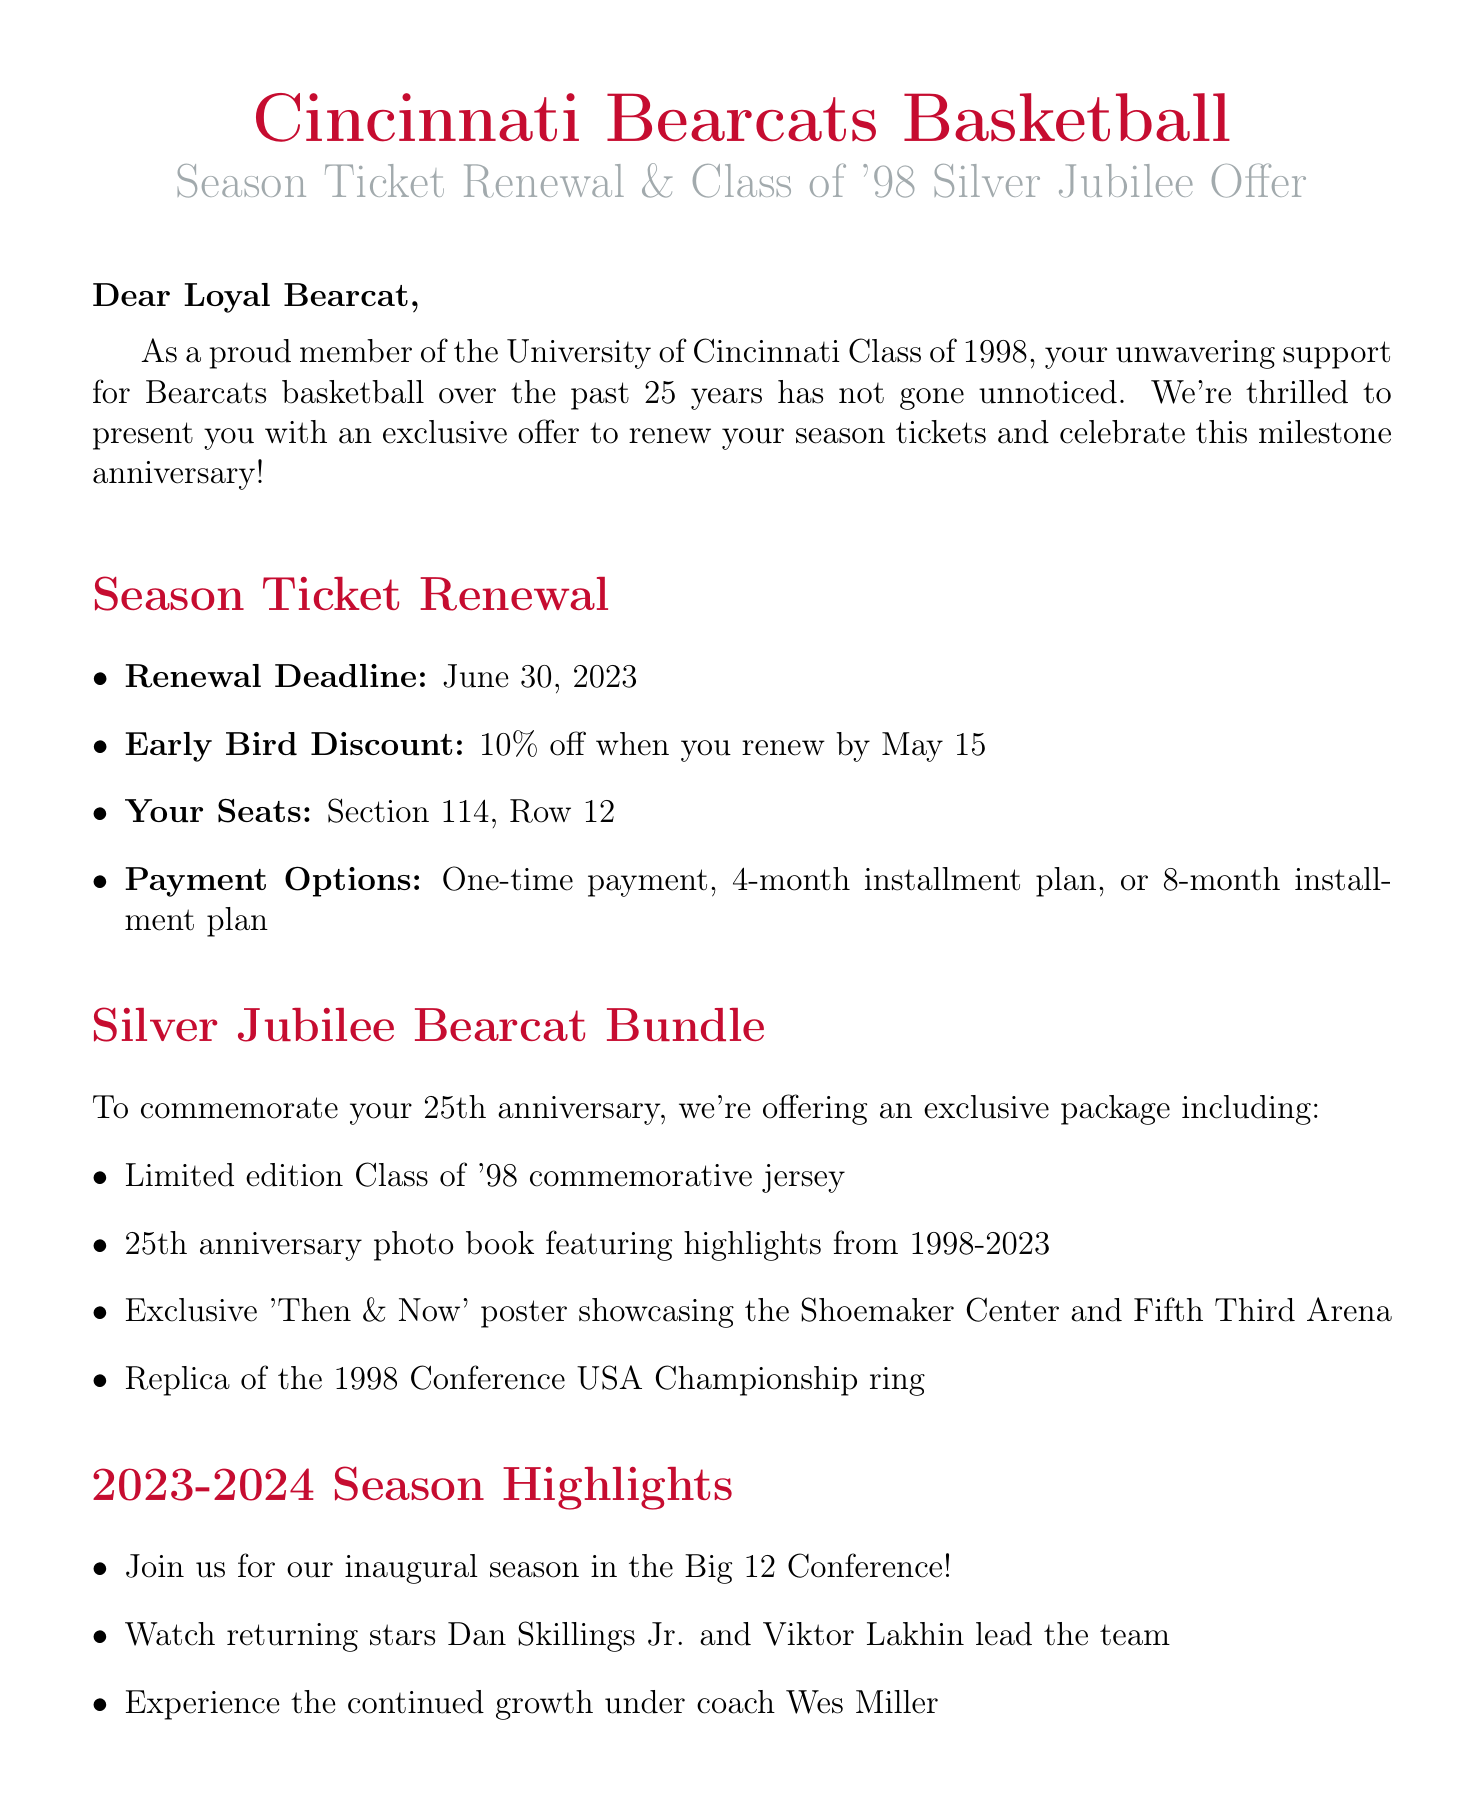What is the renewal deadline for season tickets? The renewal deadline is specifically stated in the document, providing users with the information they need to renew on time.
Answer: June 30, 2023 What discount is available for early renewals? The document highlights a specific percentage off for early renewals, which motivates quick action from fans.
Answer: 10% off What is included in the Silver Jubilee Bearcat Bundle? The document lists multiple items included in this special package, making it clear what supporters will receive.
Answer: Limited edition Class of '98 commemorative jersey, 25th anniversary photo book featuring highlights from 1998-2023, Exclusive 'Then & Now' poster showcasing the Shoemaker Center and Fifth Third Arena, Replica of the 1998 Conference USA Championship ring Who is the contact person for the Alumni Fan Experience? The document provides a specific name for alumni inquiries, ensuring fans know who to reach out to for more information.
Answer: Sarah Thompson What are the upcoming events for the Class of '98? The document itemizes important events, providing a concise schedule relevant to alumni engagement.
Answer: 25th Anniversary Class of '98 Reunion Game (November 18, 2023), Halftime ceremony honoring the '98 graduates during the home opener, Special meet-and-greet with Coach Bob Huggins before the West Virginia game Which team will the Bearcats play in their home opener? The document indicates a specific game, allowing fans to identify early matchups against well-known teams.
Answer: West Virginia 